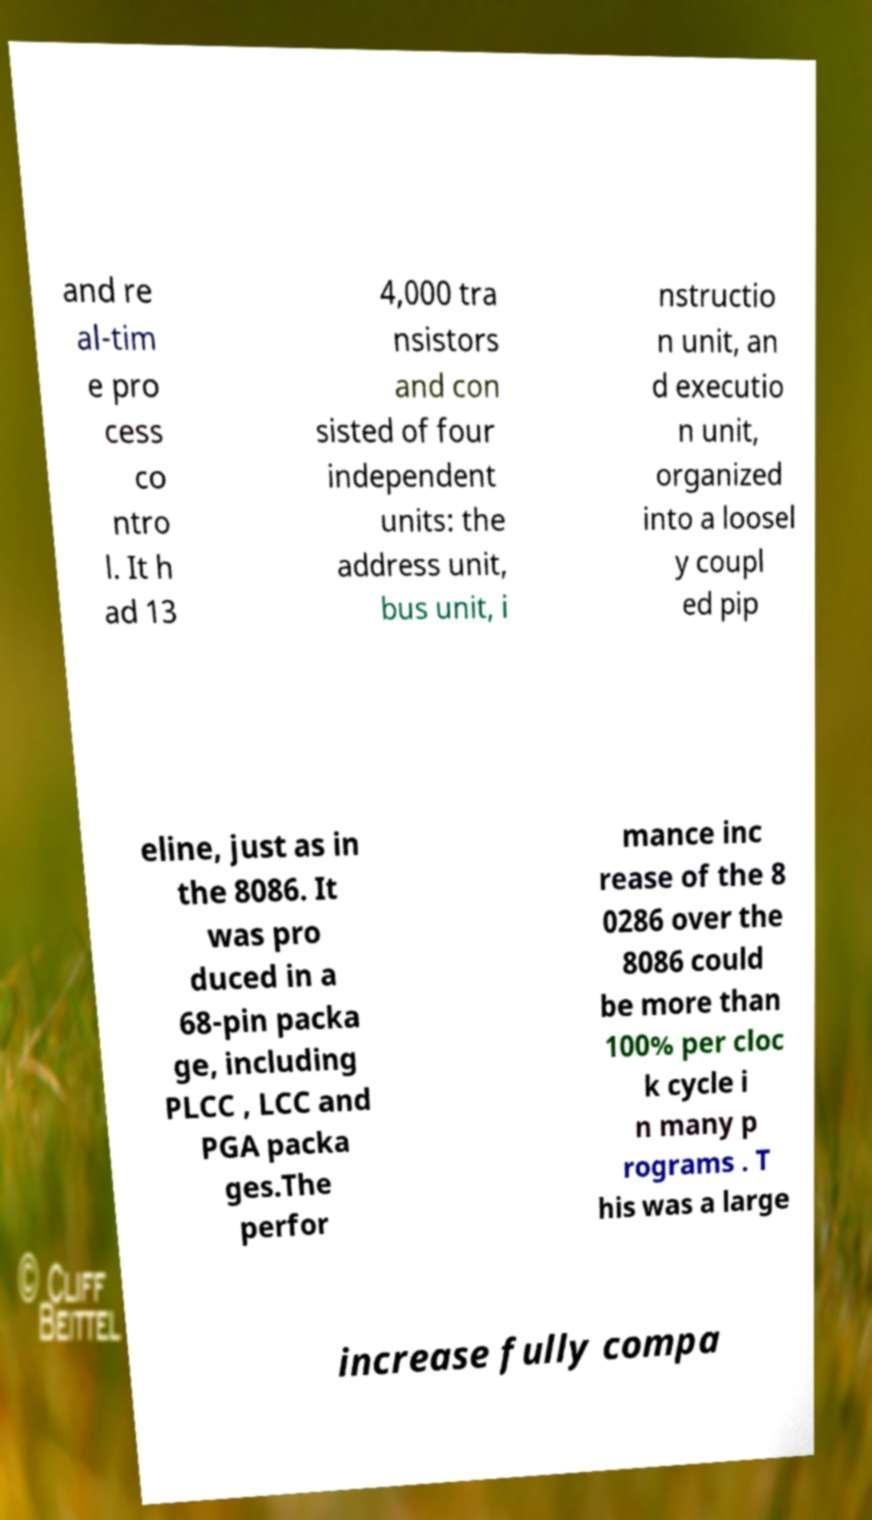Please identify and transcribe the text found in this image. and re al-tim e pro cess co ntro l. It h ad 13 4,000 tra nsistors and con sisted of four independent units: the address unit, bus unit, i nstructio n unit, an d executio n unit, organized into a loosel y coupl ed pip eline, just as in the 8086. It was pro duced in a 68-pin packa ge, including PLCC , LCC and PGA packa ges.The perfor mance inc rease of the 8 0286 over the 8086 could be more than 100% per cloc k cycle i n many p rograms . T his was a large increase fully compa 